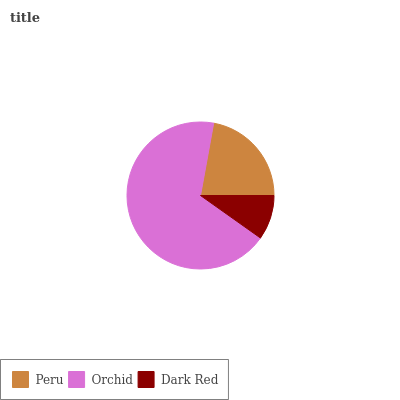Is Dark Red the minimum?
Answer yes or no. Yes. Is Orchid the maximum?
Answer yes or no. Yes. Is Orchid the minimum?
Answer yes or no. No. Is Dark Red the maximum?
Answer yes or no. No. Is Orchid greater than Dark Red?
Answer yes or no. Yes. Is Dark Red less than Orchid?
Answer yes or no. Yes. Is Dark Red greater than Orchid?
Answer yes or no. No. Is Orchid less than Dark Red?
Answer yes or no. No. Is Peru the high median?
Answer yes or no. Yes. Is Peru the low median?
Answer yes or no. Yes. Is Dark Red the high median?
Answer yes or no. No. Is Orchid the low median?
Answer yes or no. No. 